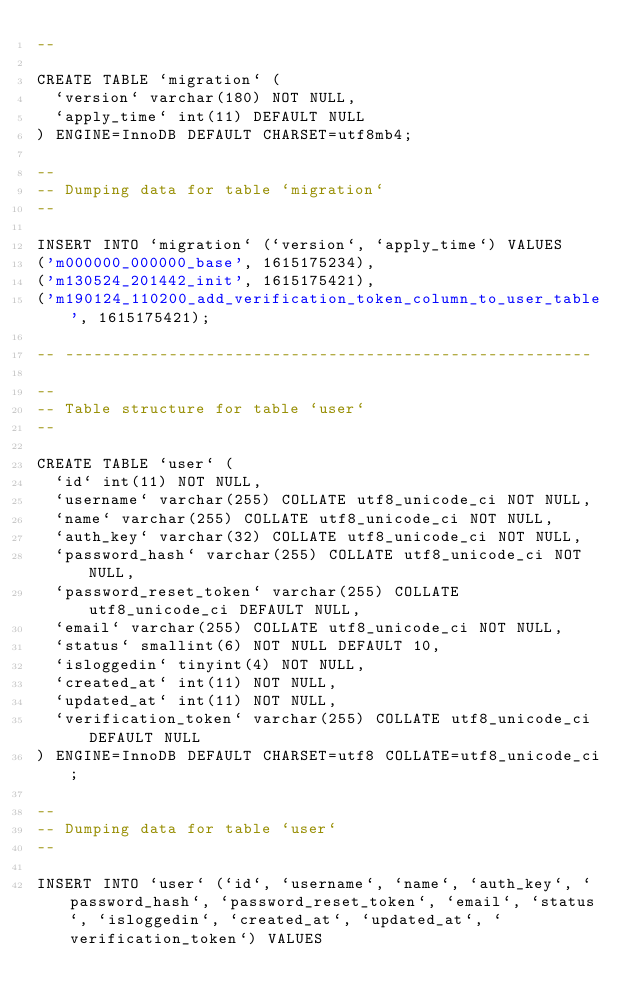<code> <loc_0><loc_0><loc_500><loc_500><_SQL_>--

CREATE TABLE `migration` (
  `version` varchar(180) NOT NULL,
  `apply_time` int(11) DEFAULT NULL
) ENGINE=InnoDB DEFAULT CHARSET=utf8mb4;

--
-- Dumping data for table `migration`
--

INSERT INTO `migration` (`version`, `apply_time`) VALUES
('m000000_000000_base', 1615175234),
('m130524_201442_init', 1615175421),
('m190124_110200_add_verification_token_column_to_user_table', 1615175421);

-- --------------------------------------------------------

--
-- Table structure for table `user`
--

CREATE TABLE `user` (
  `id` int(11) NOT NULL,
  `username` varchar(255) COLLATE utf8_unicode_ci NOT NULL,
  `name` varchar(255) COLLATE utf8_unicode_ci NOT NULL,
  `auth_key` varchar(32) COLLATE utf8_unicode_ci NOT NULL,
  `password_hash` varchar(255) COLLATE utf8_unicode_ci NOT NULL,
  `password_reset_token` varchar(255) COLLATE utf8_unicode_ci DEFAULT NULL,
  `email` varchar(255) COLLATE utf8_unicode_ci NOT NULL,
  `status` smallint(6) NOT NULL DEFAULT 10,
  `isloggedin` tinyint(4) NOT NULL,
  `created_at` int(11) NOT NULL,
  `updated_at` int(11) NOT NULL,
  `verification_token` varchar(255) COLLATE utf8_unicode_ci DEFAULT NULL
) ENGINE=InnoDB DEFAULT CHARSET=utf8 COLLATE=utf8_unicode_ci;

--
-- Dumping data for table `user`
--

INSERT INTO `user` (`id`, `username`, `name`, `auth_key`, `password_hash`, `password_reset_token`, `email`, `status`, `isloggedin`, `created_at`, `updated_at`, `verification_token`) VALUES</code> 